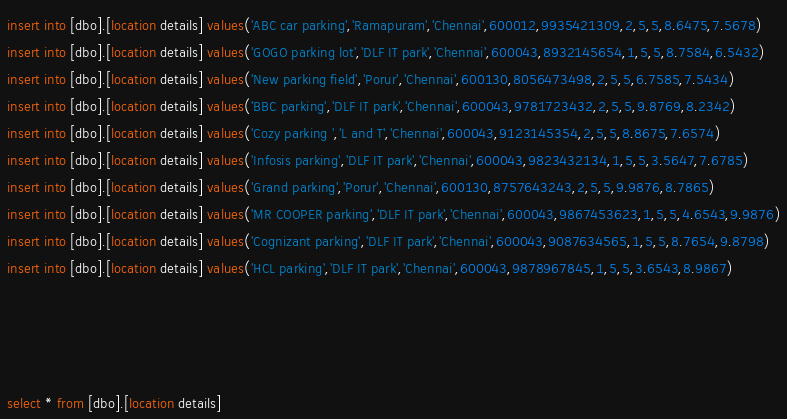Convert code to text. <code><loc_0><loc_0><loc_500><loc_500><_SQL_>insert into [dbo].[location details] values('ABC car parking','Ramapuram','Chennai',600012,9935421309,2,5,5,8.6475,7.5678)
insert into [dbo].[location details] values('GOGO parking lot','DLF IT park','Chennai',600043,8932145654,1,5,5,8.7584,6.5432)
insert into [dbo].[location details] values('New parking field','Porur','Chennai',600130,8056473498,2,5,5,6.7585,7.5434)
insert into [dbo].[location details] values('BBC parking','DLF IT park','Chennai',600043,9781723432,2,5,5,9.8769,8.2342)
insert into [dbo].[location details] values('Cozy parking ','L and T','Chennai',600043,9123145354,2,5,5,8.8675,7.6574)
insert into [dbo].[location details] values('Infosis parking','DLF IT park','Chennai',600043,9823432134,1,5,5,3.5647,7.6785)
insert into [dbo].[location details] values('Grand parking','Porur','Chennai',600130,8757643243,2,5,5,9.9876,8.7865)
insert into [dbo].[location details] values('MR COOPER parking','DLF IT park','Chennai',600043,9867453623,1,5,5,4.6543,9.9876)
insert into [dbo].[location details] values('Cognizant parking','DLF IT park','Chennai',600043,9087634565,1,5,5,8.7654,9.8798)
insert into [dbo].[location details] values('HCL parking','DLF IT park','Chennai',600043,9878967845,1,5,5,3.6543,8.9867)




select * from [dbo].[location details]</code> 